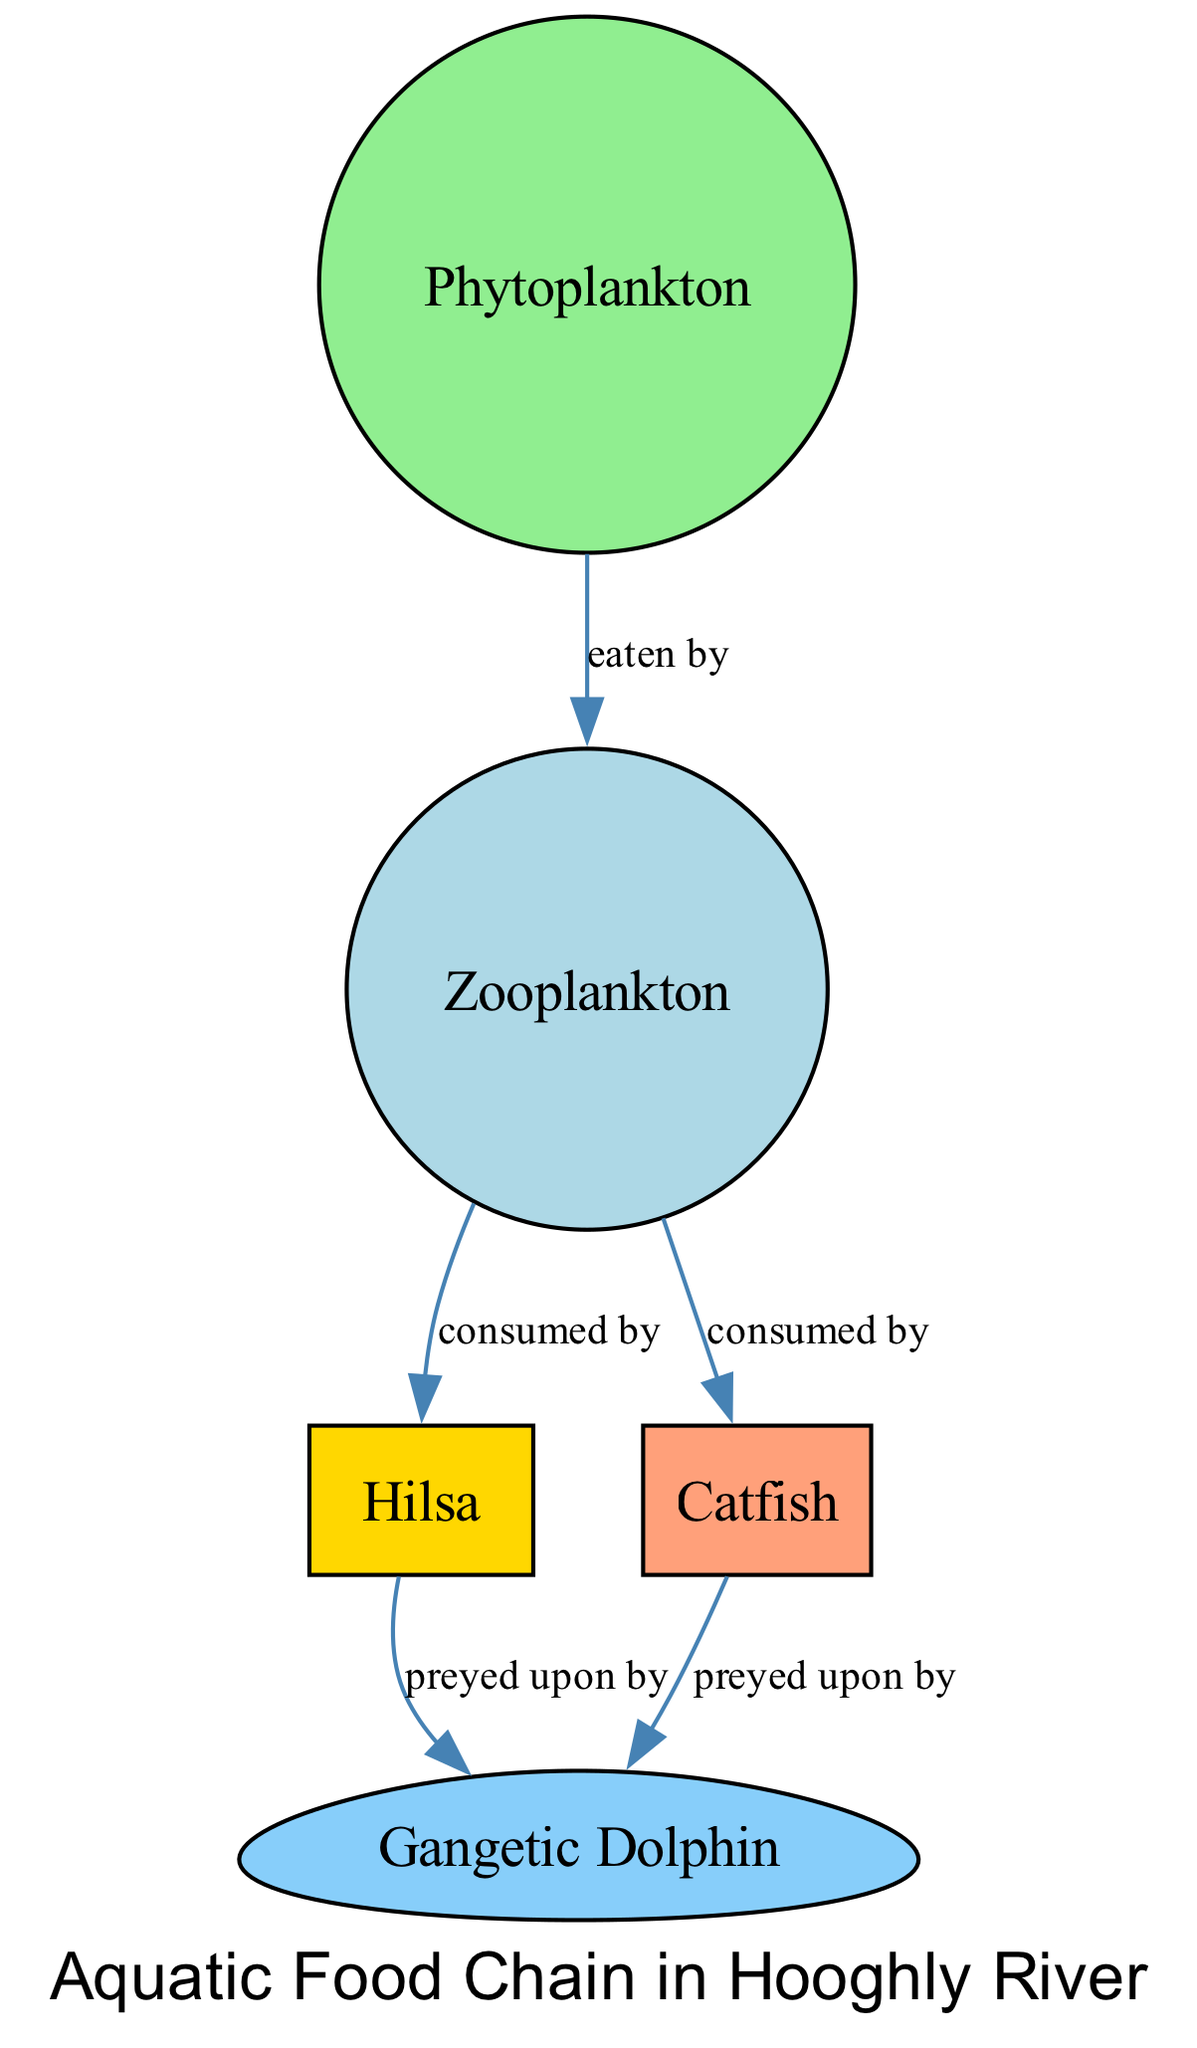What is the first node in the food chain? The first node is "Phytoplankton," which is the primary producer in the aquatic food chain, serving as the foundation for the entire ecosystem.
Answer: Phytoplankton How many nodes are present in the diagram? The nodes present in the diagram are Phytoplankton, Zooplankton, Hilsa, Catfish, and Gangetic Dolphin. Counting these gives us a total of five nodes.
Answer: 5 Which organisms consume zooplankton? According to the diagram, both "Hilsa" and "Catfish" are shown to consume Zooplankton, indicating they both depend on this planktonic life stage as food.
Answer: Hilsa and Catfish What is the relationship between phytoplankton and zooplankton? The relationship is that phytoplankton is eaten by zooplankton, indicating a direct predator-prey dynamic where zooplankton relies on phytoplankton for sustenance.
Answer: eaten by Who preys on both hilsa and catfish? The diagram indicates that the "Gangetic Dolphin" preys on both Hilsa and Catfish, showcasing its position as a larger predator in the food chain.
Answer: Gangetic Dolphin Which two organisms are at the top of the food chain? The top organisms in the aquatic food chain as illustrated in the diagram are "Hilsa" and "Catfish," which are consumed by the Gangetic Dolphin, representing the apex predators.
Answer: Hilsa and Catfish How many edges are depicted in the diagram? The edges represent the relationships between the nodes. Counting the edges, we can see there are five connections showing the flow of energy and feeding relationships.
Answer: 5 What type of species is Gangetic Dolphin in this food chain? The Gangetic Dolphin is a top predator in this aquatic food chain, particularly significant because it preys on both smaller fish like hilsa and catfish, indicating its ecological role.
Answer: top predator What is the second node in the food chain? The second node is "Zooplankton," which is the primary consumer, relying on phytoplankton for energy within the food chain.
Answer: Zooplankton 